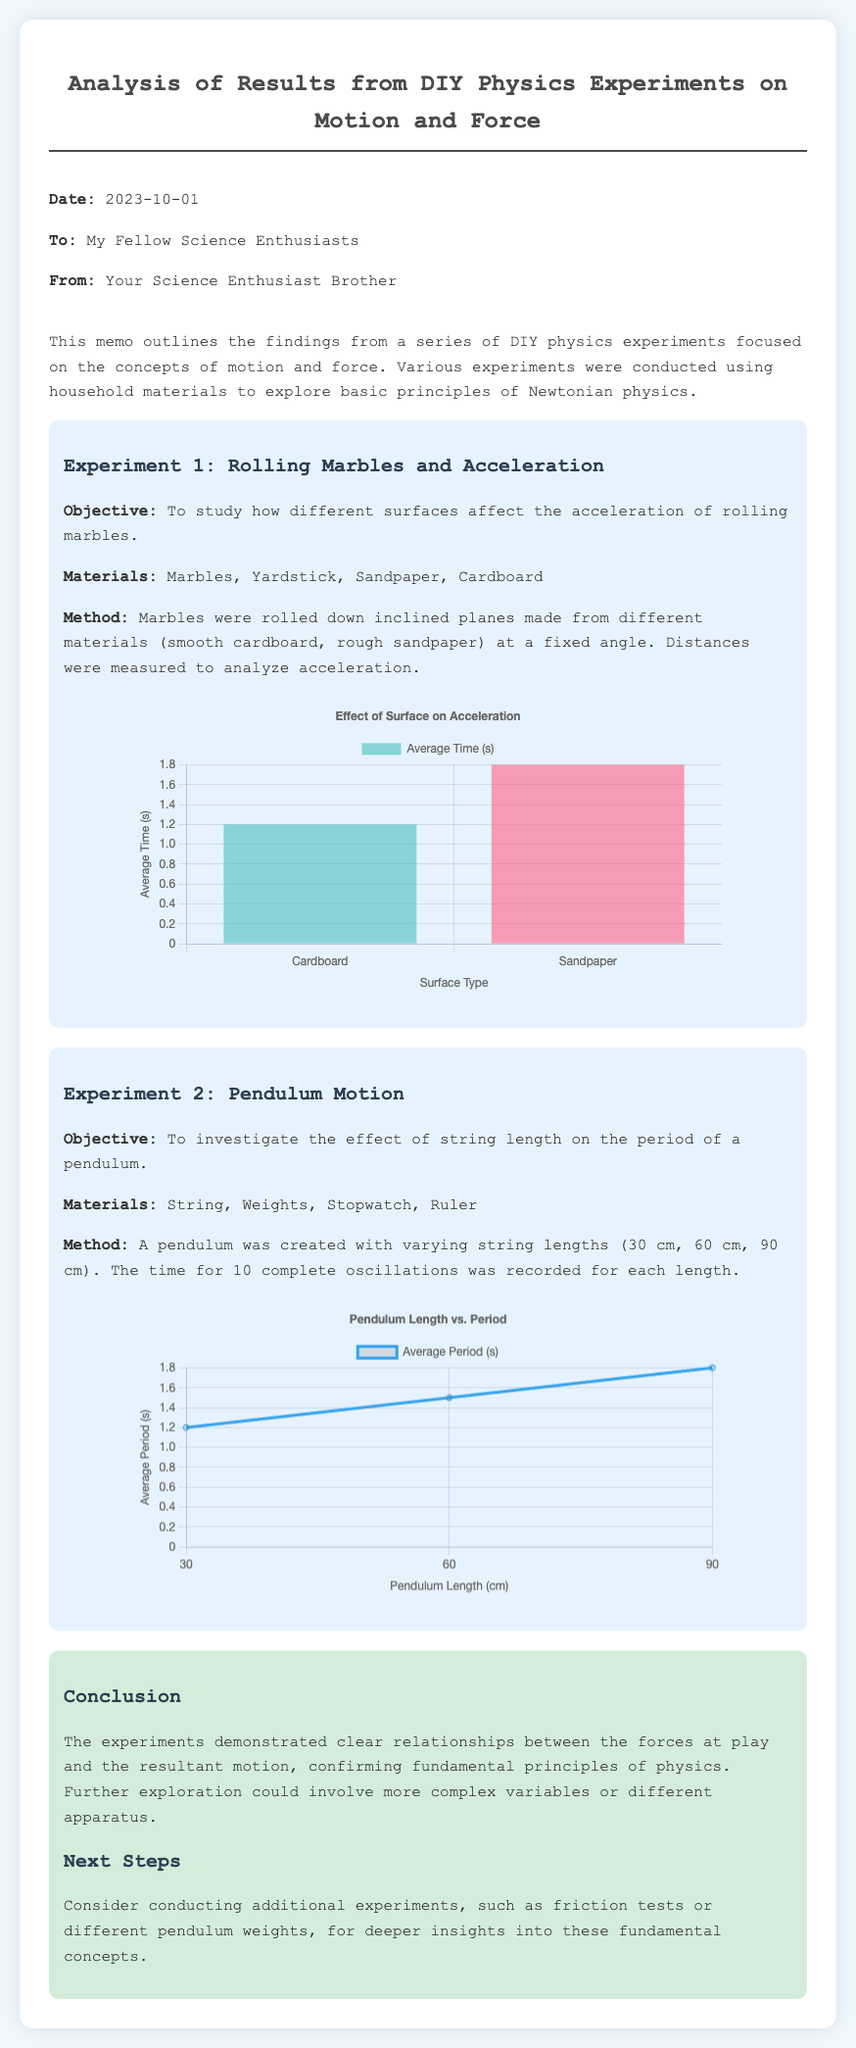What is the date of the memo? The date of the memo is explicitly stated at the top, which is 2023-10-01.
Answer: 2023-10-01 Who is the memo addressed to? The memo mentions that it is addressed to "My Fellow Science Enthusiasts" in the header section.
Answer: My Fellow Science Enthusiasts What are the two surfaces used in Experiment 1? The surfaces used in Experiment 1 are listed as "smooth cardboard" and "rough sandpaper".
Answer: smooth cardboard, rough sandpaper What is the objective of Experiment 2? The objective of Experiment 2 is clearly defined as investigating the effect of string length on the period of a pendulum.
Answer: Investigate the effect of string length on the period of a pendulum What is the average period for a 60 cm pendulum? The average period for a 60 cm pendulum is indicated in the data of the pendulum chart as 1.5 seconds.
Answer: 1.5 seconds What does the chart for the marble experiment depict? The chart for the marble experiment illustrates the average time taken on different surface types for acceleration.
Answer: Average Time on Surface Types Which material resulted in a longer average time for acceleration? The longer average time for acceleration is shown in the marble chart to be on "Sandpaper".
Answer: Sandpaper What were the string lengths used in Experiment 2? The string lengths used in Experiment 2 are listed in the document as 30 cm, 60 cm, and 90 cm.
Answer: 30 cm, 60 cm, 90 cm What is the conclusion drawn from the experiments? The conclusion summarizes that the experiments demonstrate clear relationships between the forces and the resultant motion, confirming fundamental physics principles.
Answer: Confirming fundamental principles of physics 